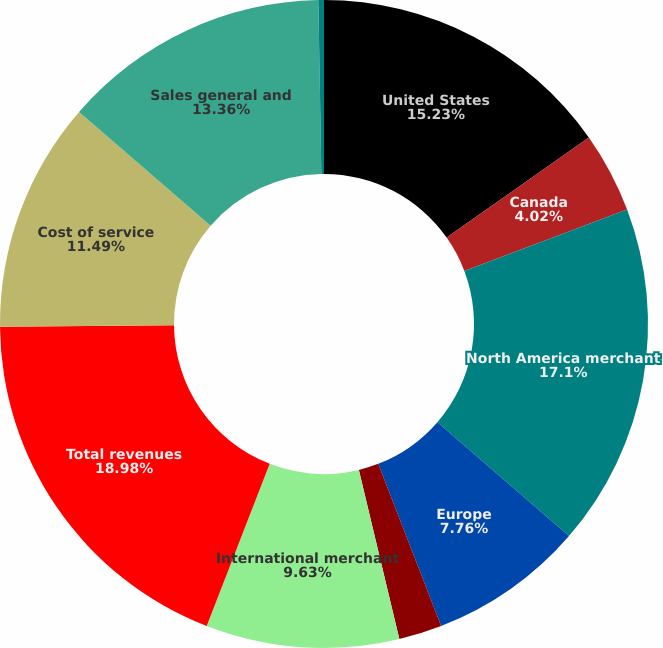Convert chart. <chart><loc_0><loc_0><loc_500><loc_500><pie_chart><fcel>United States<fcel>Canada<fcel>North America merchant<fcel>Europe<fcel>Asia-Pacific<fcel>International merchant<fcel>Total revenues<fcel>Cost of service<fcel>Sales general and<fcel>Processing system intrusion<nl><fcel>15.23%<fcel>4.02%<fcel>17.1%<fcel>7.76%<fcel>2.15%<fcel>9.63%<fcel>18.97%<fcel>11.49%<fcel>13.36%<fcel>0.28%<nl></chart> 